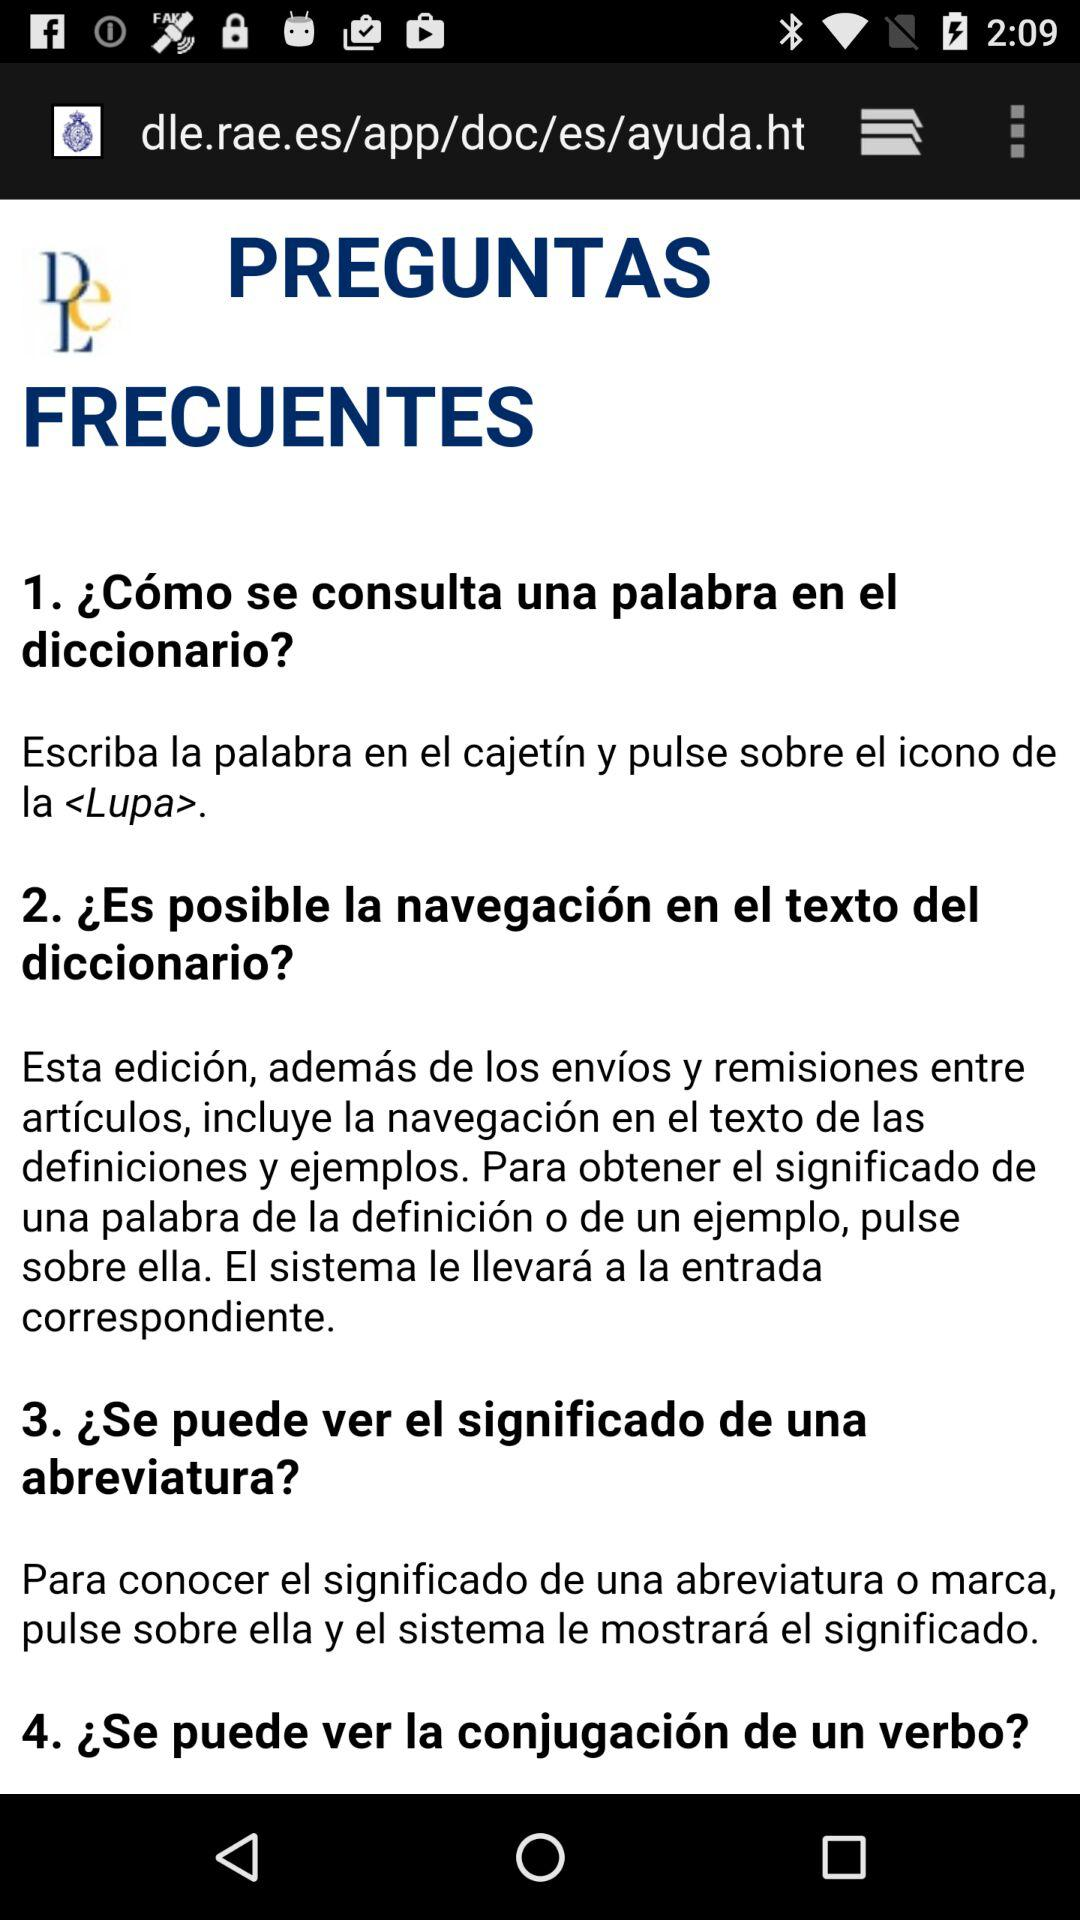How many questions are there in the FAQ section?
Answer the question using a single word or phrase. 4 